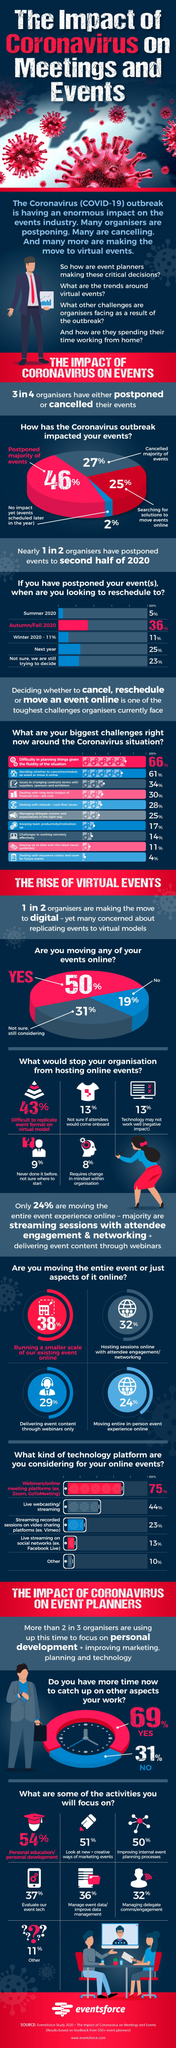Outline some significant characteristics in this image. A majority of event organizers, 46%, have postponed events as a result of the pandemic. According to a survey, 43% of event organizers reported difficulty in replicating their events in a virtual model. Dealing with refunds and cash flow issues is listed as the fifth challenge faced by event organizers. Thirty-eight percent of the event organizers plan to conduct a smaller scale version of the event online. It is expected that 25% of the organizers will host events online. 